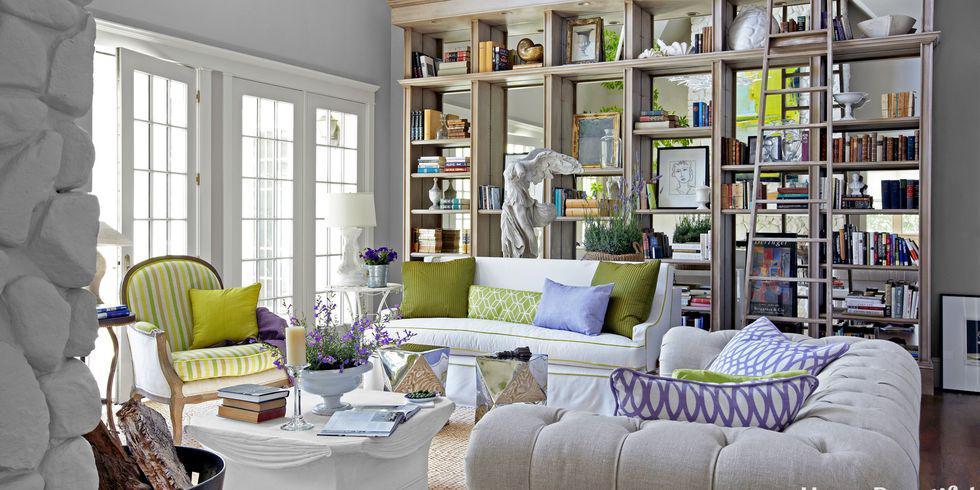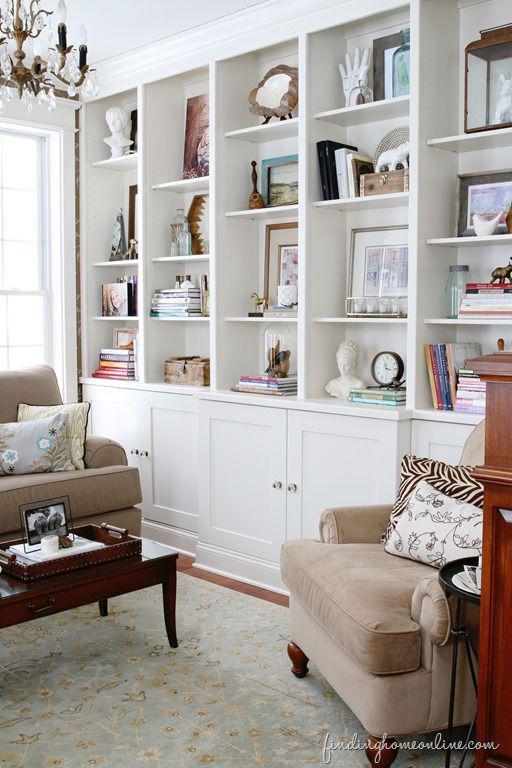The first image is the image on the left, the second image is the image on the right. Considering the images on both sides, is "One image is a room with a chandelier and a white bookcase that fills a wall." valid? Answer yes or no. Yes. 